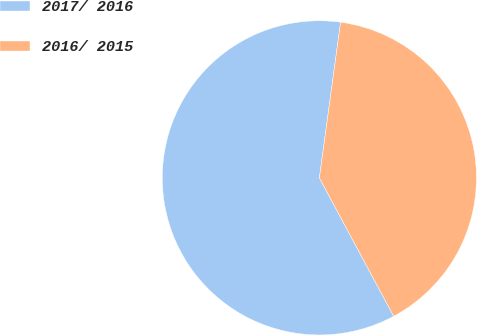<chart> <loc_0><loc_0><loc_500><loc_500><pie_chart><fcel>2017/ 2016<fcel>2016/ 2015<nl><fcel>60.0%<fcel>40.0%<nl></chart> 